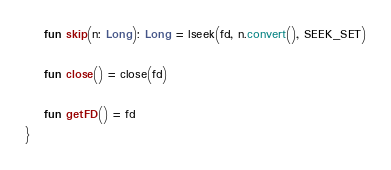<code> <loc_0><loc_0><loc_500><loc_500><_Kotlin_>
    fun skip(n: Long): Long = lseek(fd, n.convert(), SEEK_SET)

    fun close() = close(fd)

    fun getFD() = fd
}
</code> 